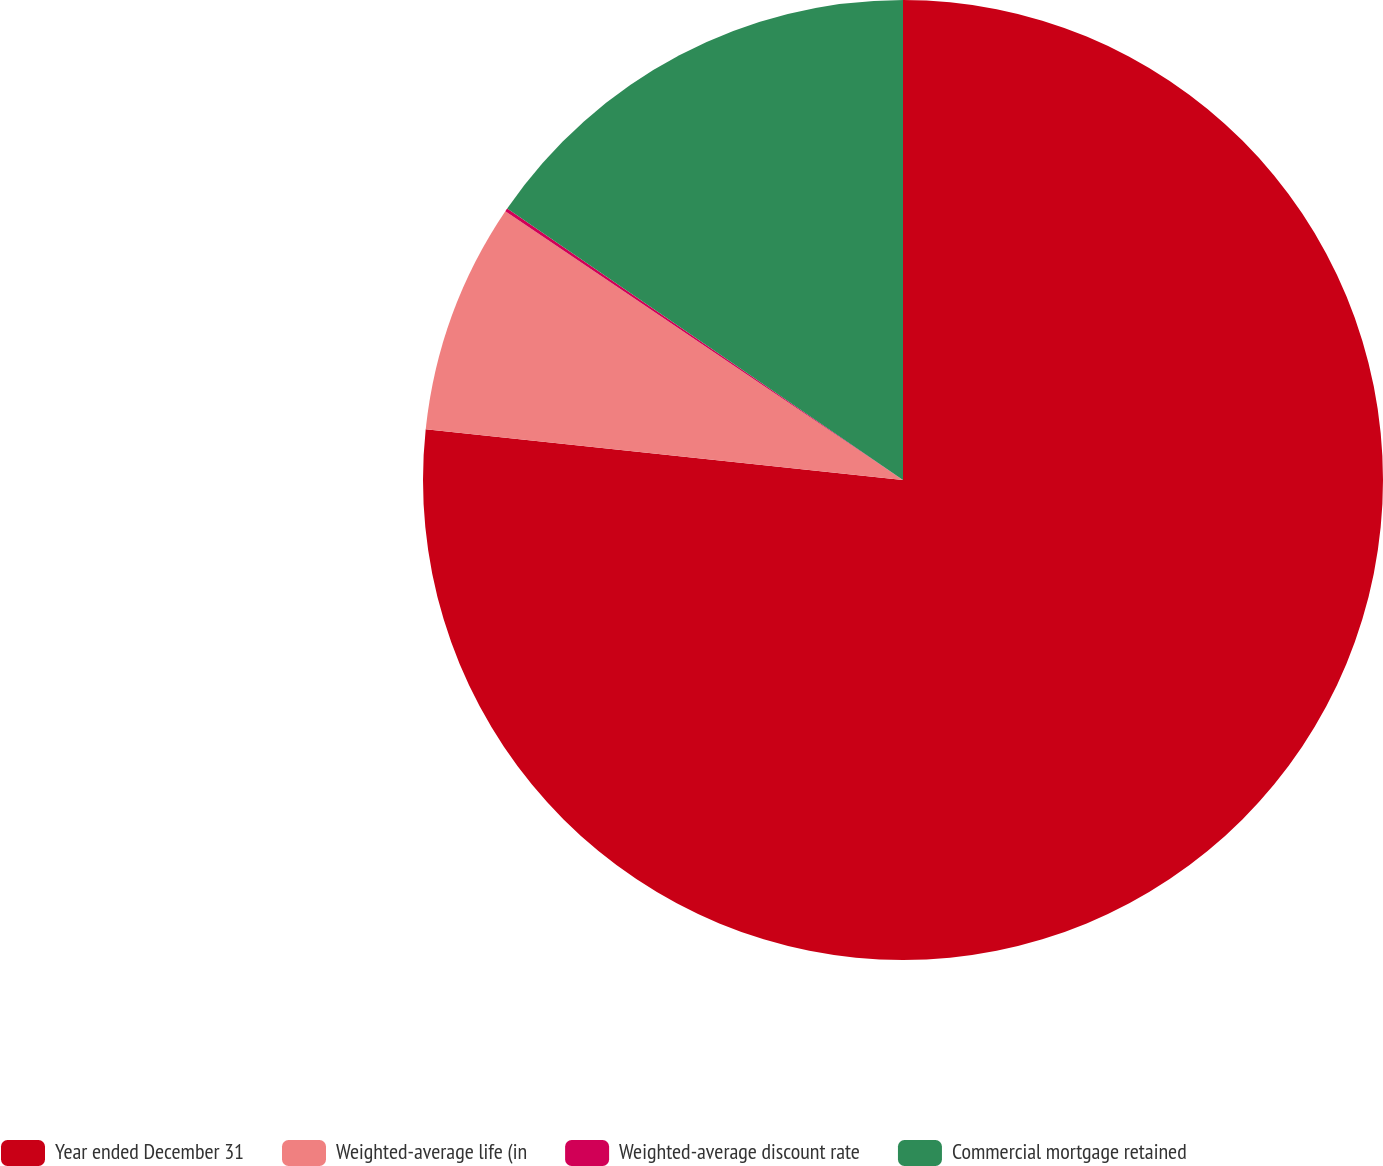<chart> <loc_0><loc_0><loc_500><loc_500><pie_chart><fcel>Year ended December 31<fcel>Weighted-average life (in<fcel>Weighted-average discount rate<fcel>Commercial mortgage retained<nl><fcel>76.69%<fcel>7.77%<fcel>0.11%<fcel>15.43%<nl></chart> 